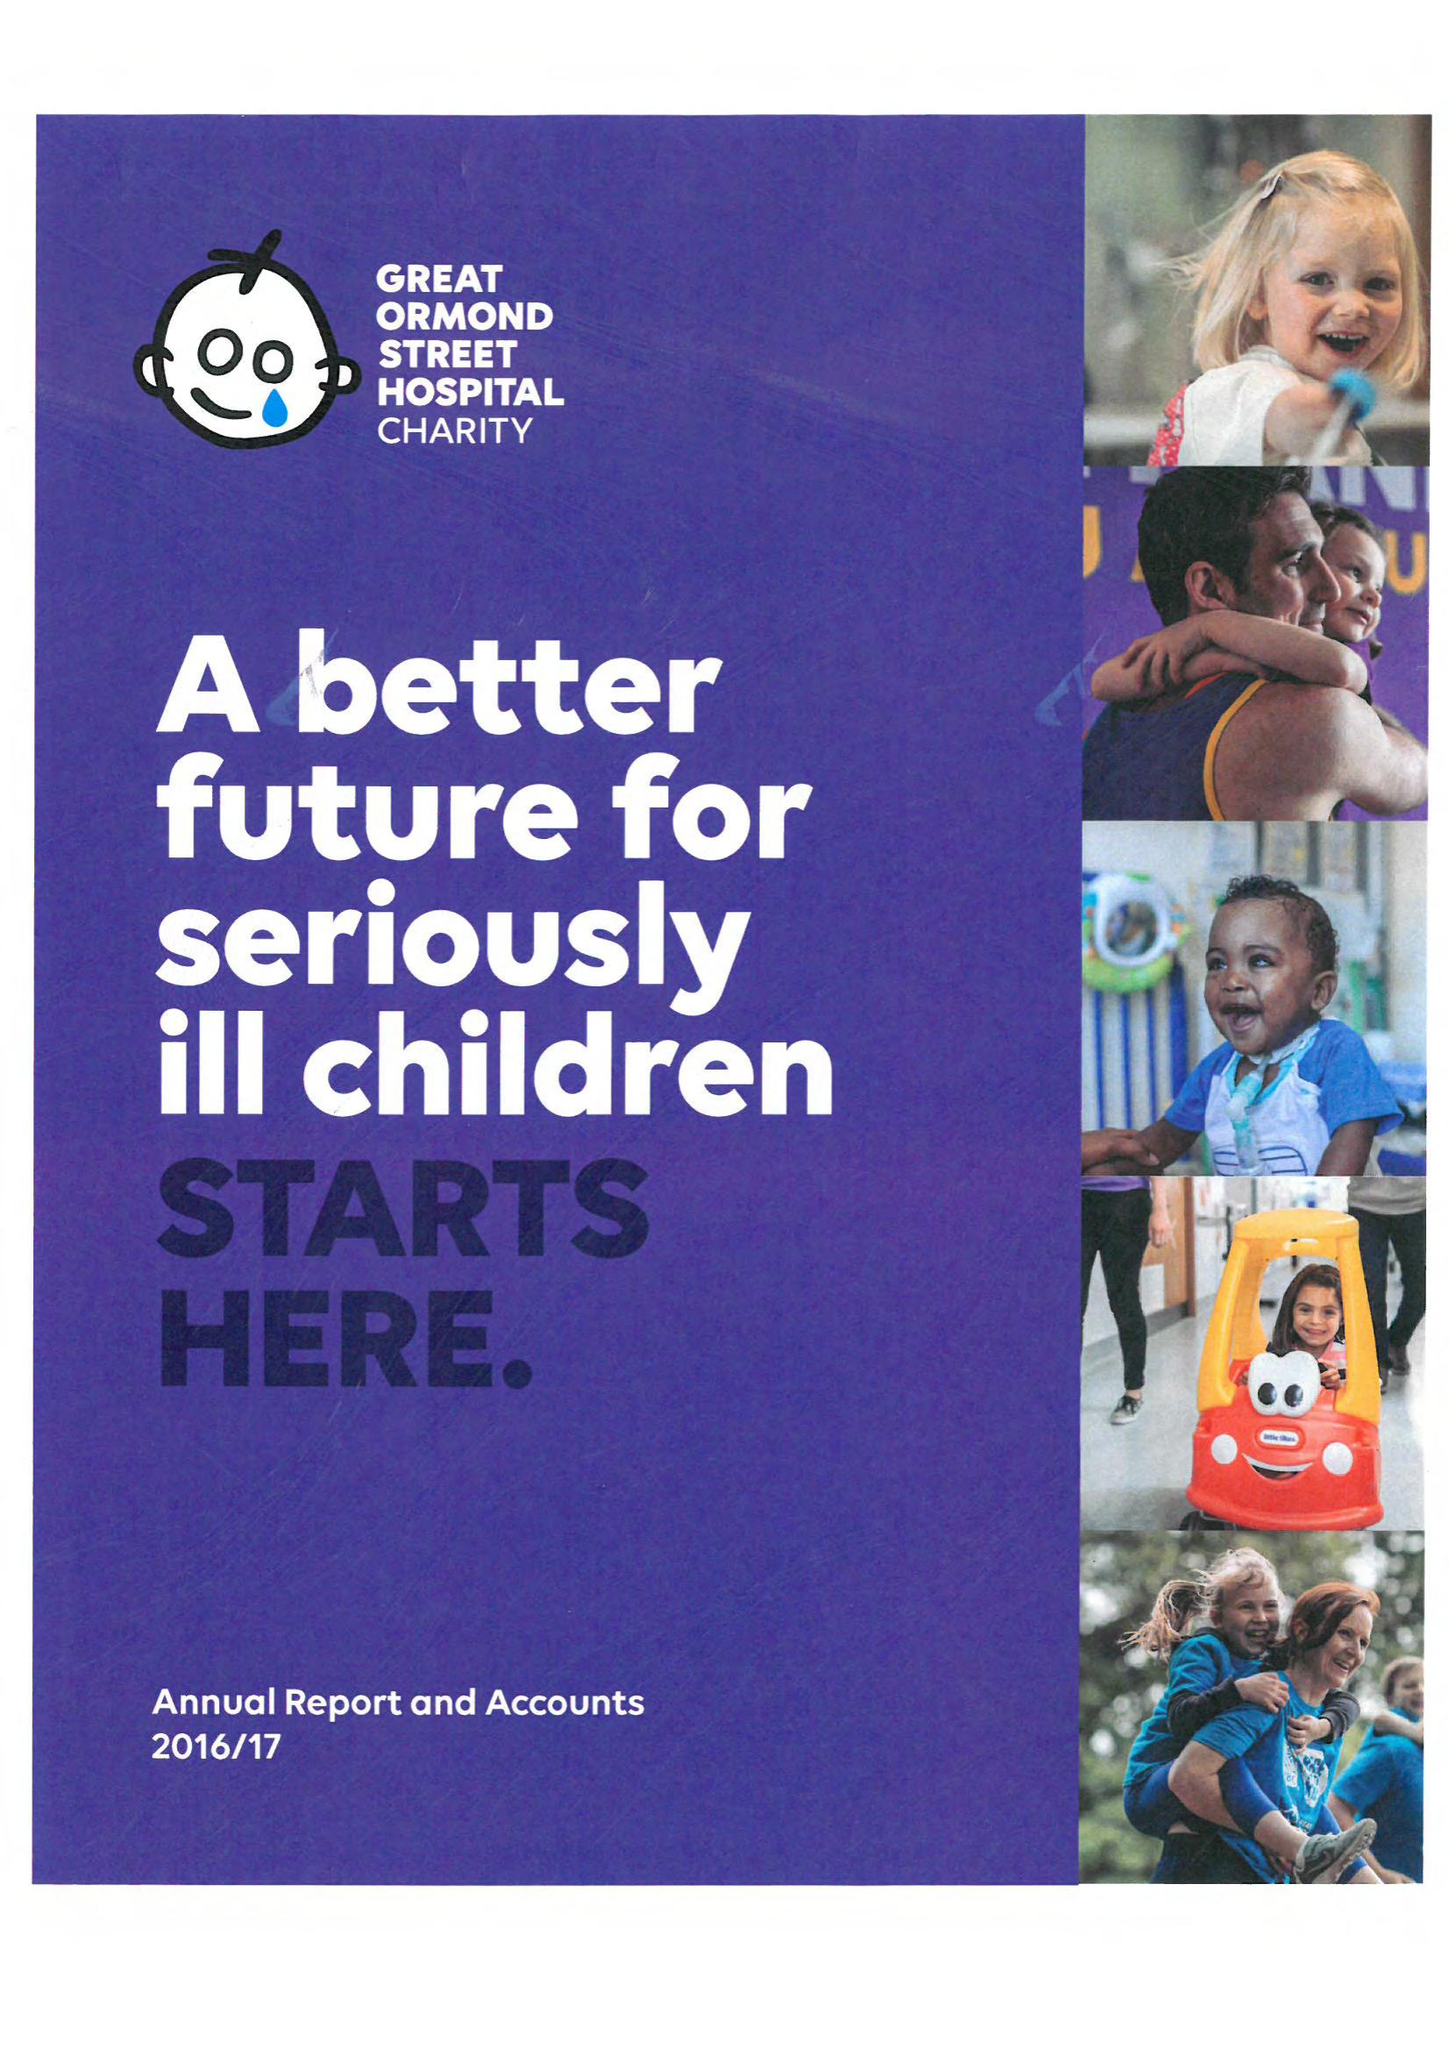What is the value for the spending_annually_in_british_pounds?
Answer the question using a single word or phrase. 87446977.00 